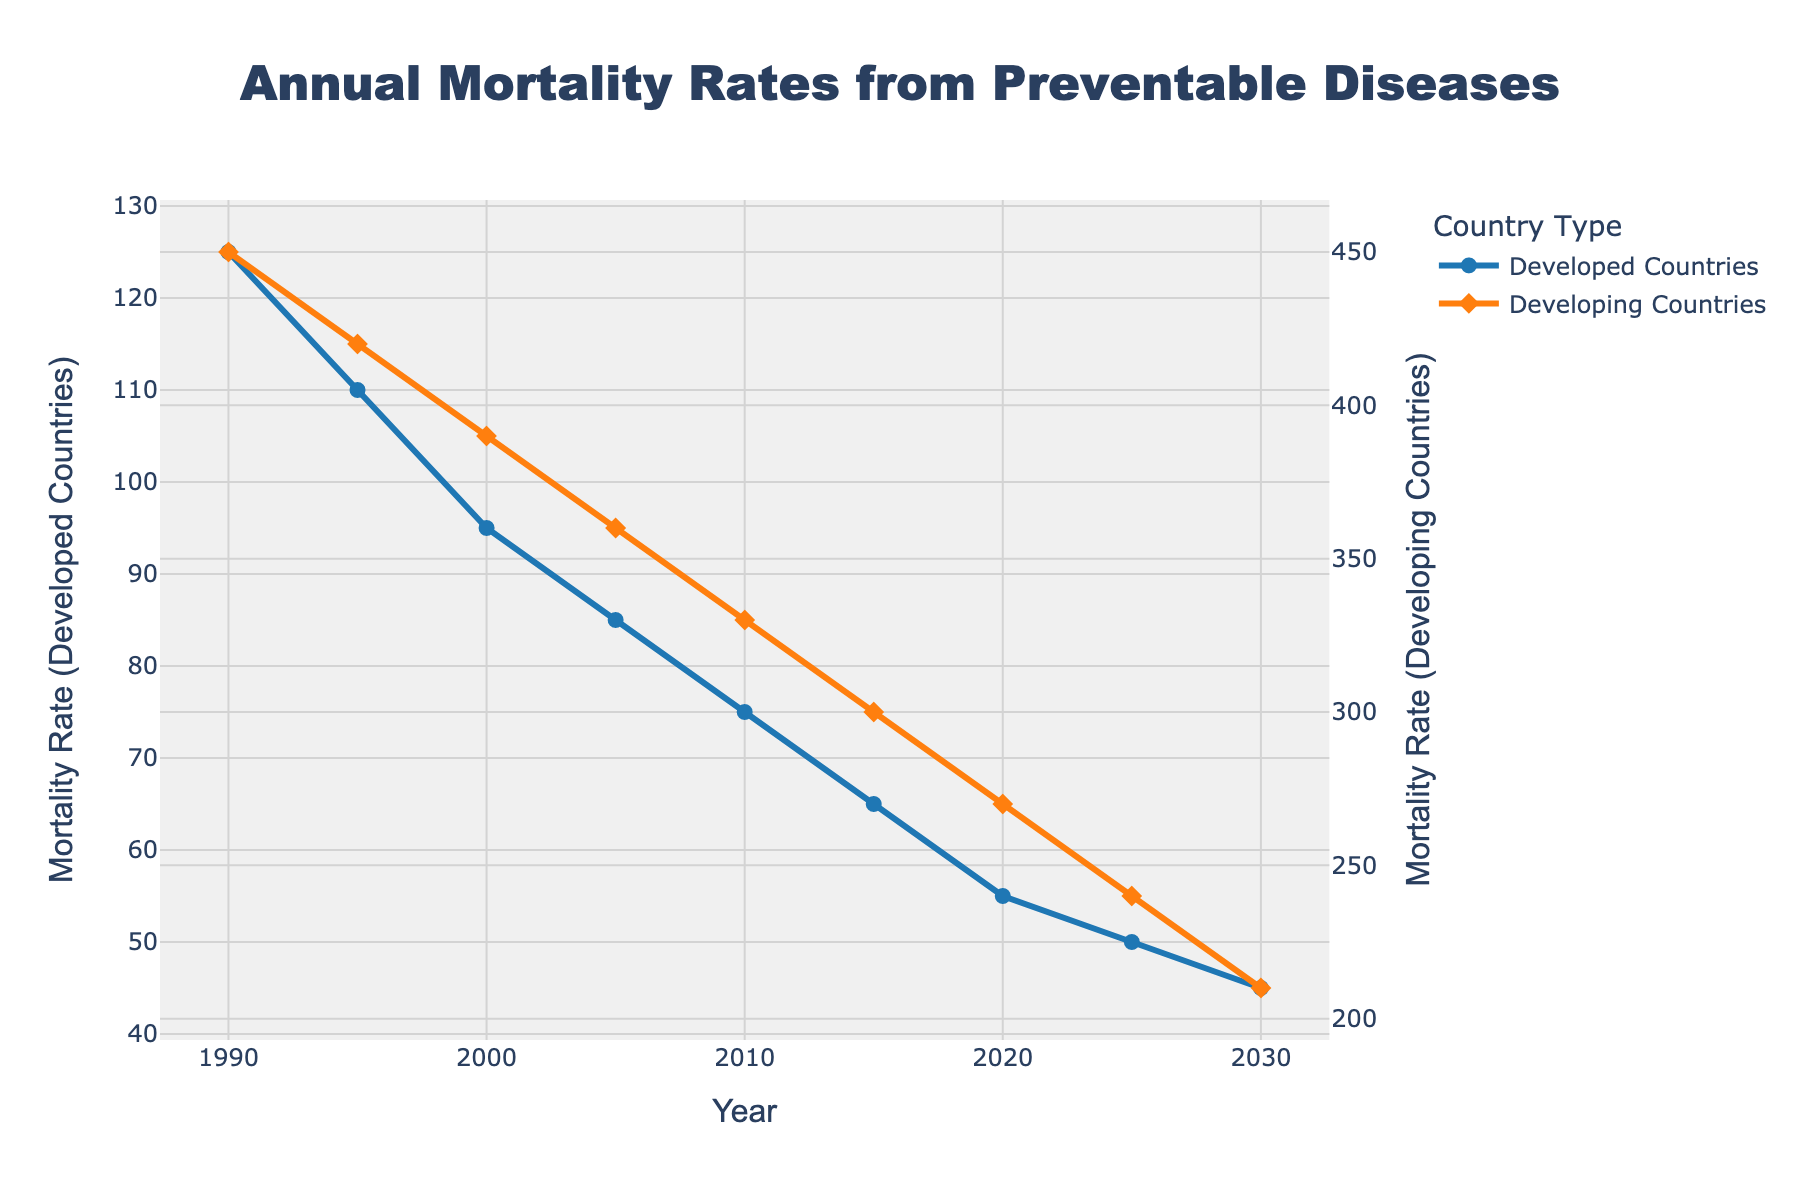What's the difference in mortality rates between developed and developing countries in 1990? The mortality rate for developed countries in 1990 is 125, and for developing countries, it is 450. The difference is calculated as 450 - 125.
Answer: 325 What is the general trend in mortality rates for developed countries from 1990 to 2030? The mortality rates for developed countries are 125 (1990), 110 (1995), 95 (2000), 85 (2005), 75 (2010), 65 (2015), 55 (2020), 50 (2025), and 45 (2030). This indicates a general downward trend.
Answer: Downward Which year shows the smallest gap between mortality rates of developed and developing countries? In 2030, the mortality rates are 45 for developed countries and 210 for developing countries. The gap is 210 - 45 = 165, which is the smallest compared to other years.
Answer: 2030 What are the average annual mortality rates for developed and developing countries over the period shown? For developed countries: (125 + 110 + 95 + 85 + 75 + 65 + 55 + 50 + 45)/9. For developing countries: (450 + 420 + 390 + 360 + 330 + 300 + 270 + 240 + 210)/9. Calculating the sums: Developed = 705, Developing = 2970. Averages: Developed = 705/9 ≈ 78.33, Developing = 2970/9 ≈ 330.
Answer: Developed ≈ 78.33, Developing ≈ 330 How much did the mortality rate in developing countries decrease from 1990 to 2020? Mortality rate for developing countries in 1990 is 450, and in 2020 it is 270. The decrease is 450 - 270.
Answer: 180 What is the median mortality rate for developed countries? The data points for developed countries are: 125, 110, 95, 85, 75, 65, 55, 50, and 45. Ordering them: 45, 50, 55, 65, 75, 85, 95, 110, 125. The median value is the middle one in this ordered list.
Answer: 75 From which year did the mortality rate in developed countries drop below 100? From the data: 1990 (125), 1995 (110), 2000 (95). The rate dropped below 100 in the year 2000.
Answer: 2000 Between which two consecutive periods did developing countries see the highest reduction in mortality rates? Calculating differences: 1990-1995: 450-420=30, 1995-2000: 420-390=30, 2000-2005: 390-360=30, 2005-2010: 360-330=30, 2010-2015: 330-300=30, 2015-2020: 300-270=30, 2020-2025: 270-240=30, 2025-2030: 240-210=30. All differences are 30, so any pair of consecutive years would suffice.
Answer: Any consecutive periods have similar reduction (30) 